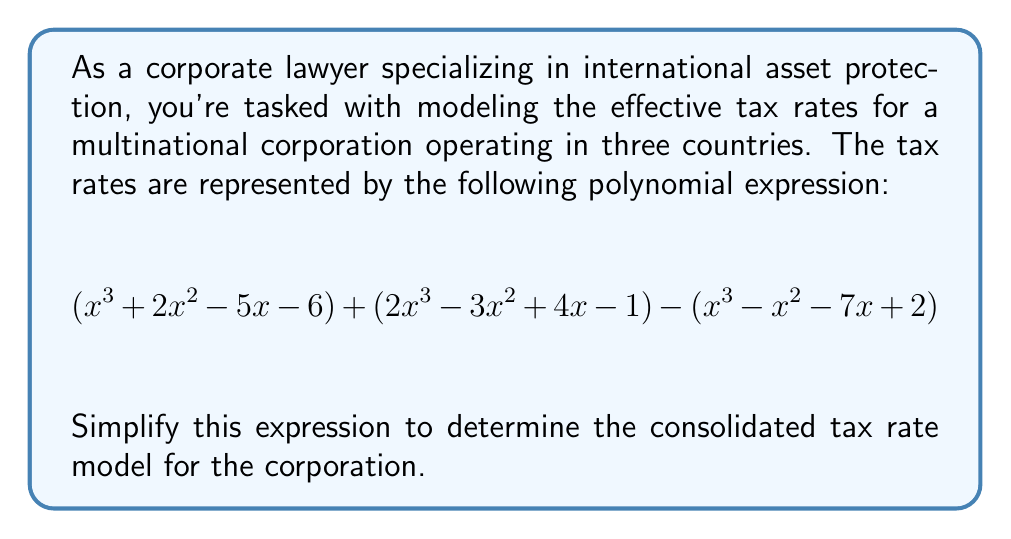Can you answer this question? To simplify this complex polynomial expression, we'll follow these steps:

1) First, we'll group like terms from all three polynomials:

   $$(x^3 + 2x^2 - 5x - 6) + (2x^3 - 3x^2 + 4x - 1) - (x^3 - x^2 - 7x + 2)$$

2) Now, let's combine the coefficients of like terms:

   For $x^3$: $1 + 2 - 1 = 2$
   For $x^2$: $2 - 3 + 1 = 0$
   For $x$: $-5 + 4 + 7 = 6$
   Constants: $-6 - 1 - 2 = -9$

3) Rewriting the simplified polynomial:

   $$2x^3 + 0x^2 + 6x - 9$$

4) We can further simplify by removing the term with zero coefficient:

   $$2x^3 + 6x - 9$$

5) This polynomial cannot be factored further, so this is our final simplified expression.

The resulting polynomial represents the consolidated tax rate model for the corporation, where $x$ could represent a variable such as income or asset value, depending on how the original polynomials were constructed.
Answer: $$2x^3 + 6x - 9$$ 